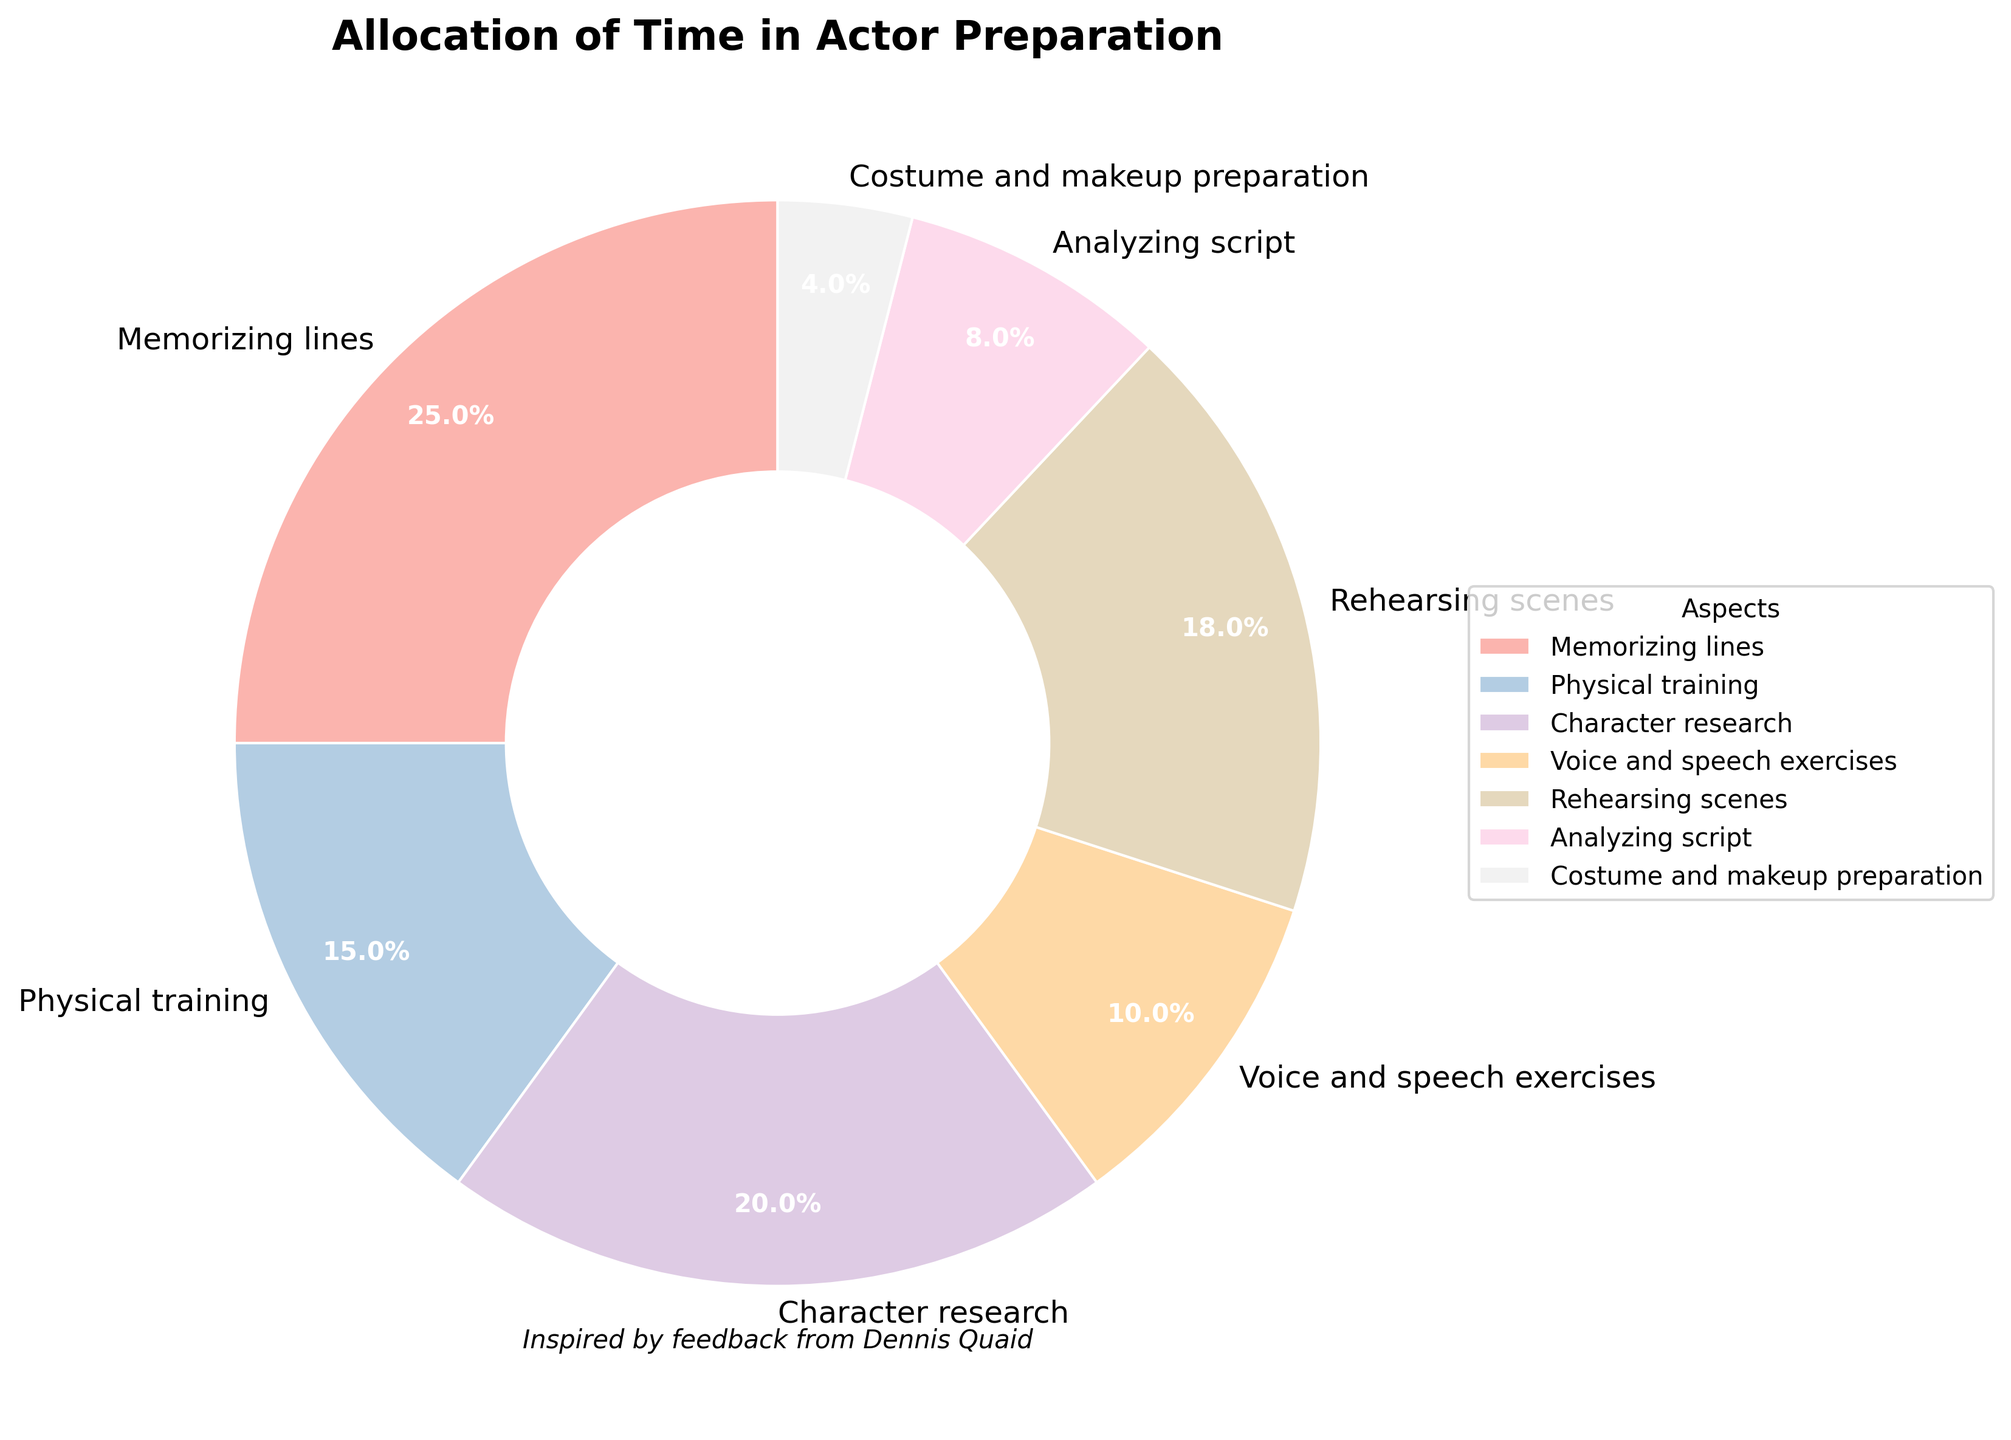What's the largest section of the pie chart? The segment labeled "Memorizing lines" occupies the greatest share of the pie chart at 25%. Look for the largest slice when interpreting the figure.
Answer: Memorizing lines (25%) What's the difference in percentage between the time spent on physical training and character research? Physical training is 15%, and character research is 20%. Subtract 15 from 20 to find the difference.
Answer: 5% Which aspect takes up the least amount of time? The smallest slice represents "Costume and makeup preparation" which is 4%. Look for the smallest slice in the pie chart.
Answer: Costume and makeup preparation (4%) Compare the time spent on voice and speech exercises with analyzing the script. Which one is higher, and by how much? Voice and speech exercises take up 10%, while analyzing the script accounts for 8%. Subtract 8 from 10 to find the difference.
Answer: Voice and speech exercises by 2% What is the total percentage of time allocated to rehearsing scenes and memorizing lines combined? Rehearsing scenes is 18% and memorizing lines is 25%. Add these together: 18 + 25 = 43%.
Answer: 43% If character research and physical training were to swap their time allocations, what would the new percentages be? Character research is 20% and physical training is 15%. If swapped, character research would be 15% and physical training would be 20%.
Answer: Character research: 15%, Physical training: 20% Which aspect takes up more time: voice and speech exercises or costume and makeup preparation, and what is the difference in their percentages? Voice and speech exercises occupy 10%, while costume and makeup preparation occupies 4%. Subtract 4 from 10 to find the difference.
Answer: Voice and speech exercises by 6% Combine the percentage of time spent on analyzing the script and physical training. How much is it? Analyzing the script is 8% and physical training is 15%. Add these together: 8 + 15 = 23%.
Answer: 23% Is the time spent on character research higher or lower than the average time spent on all aspects? To find the average, sum all percentages and divide by the number of aspects: (25 + 15 + 20 + 10 + 18 + 8 + 4) / 7 = 100 / 7 ≈ 14.29%. Character research is 20%, which is higher.
Answer: Higher 